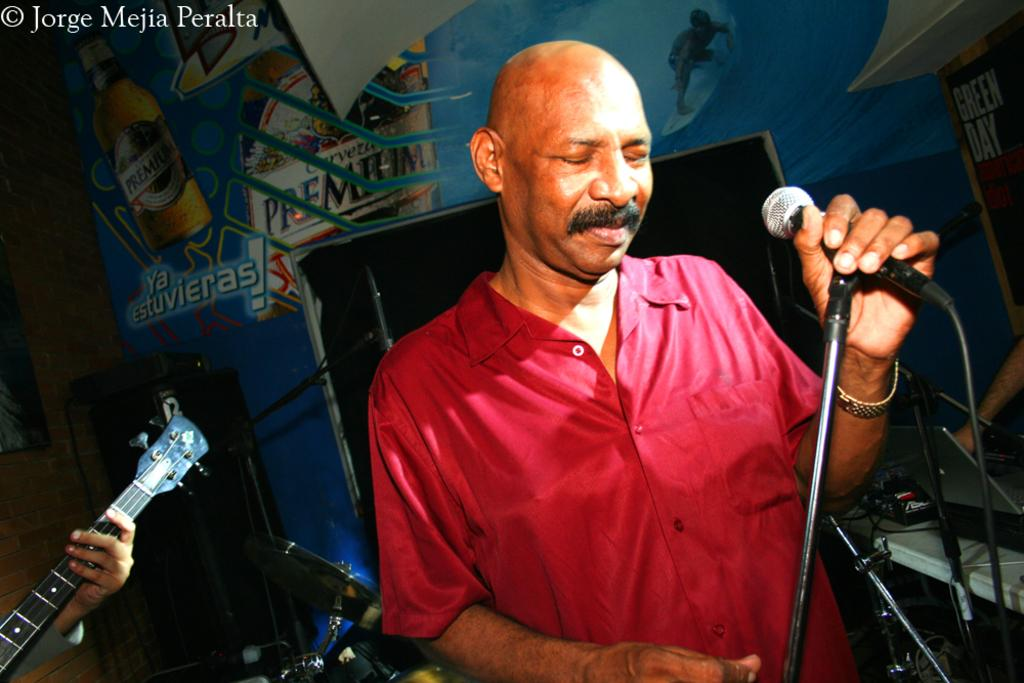Who is present in the image? There is a man in the image. What is the man doing in the image? The man is standing in the image. What object is the man holding in his hands? The man is holding a microphone in his hands. What can be seen on the same plane as the man in the image? There is a table in the image. What is visible in the background of the image? There is a wall visible in the background of the image. How many sheep can be seen swimming in the background of the image? There are no sheep or swimming activity present in the image. 